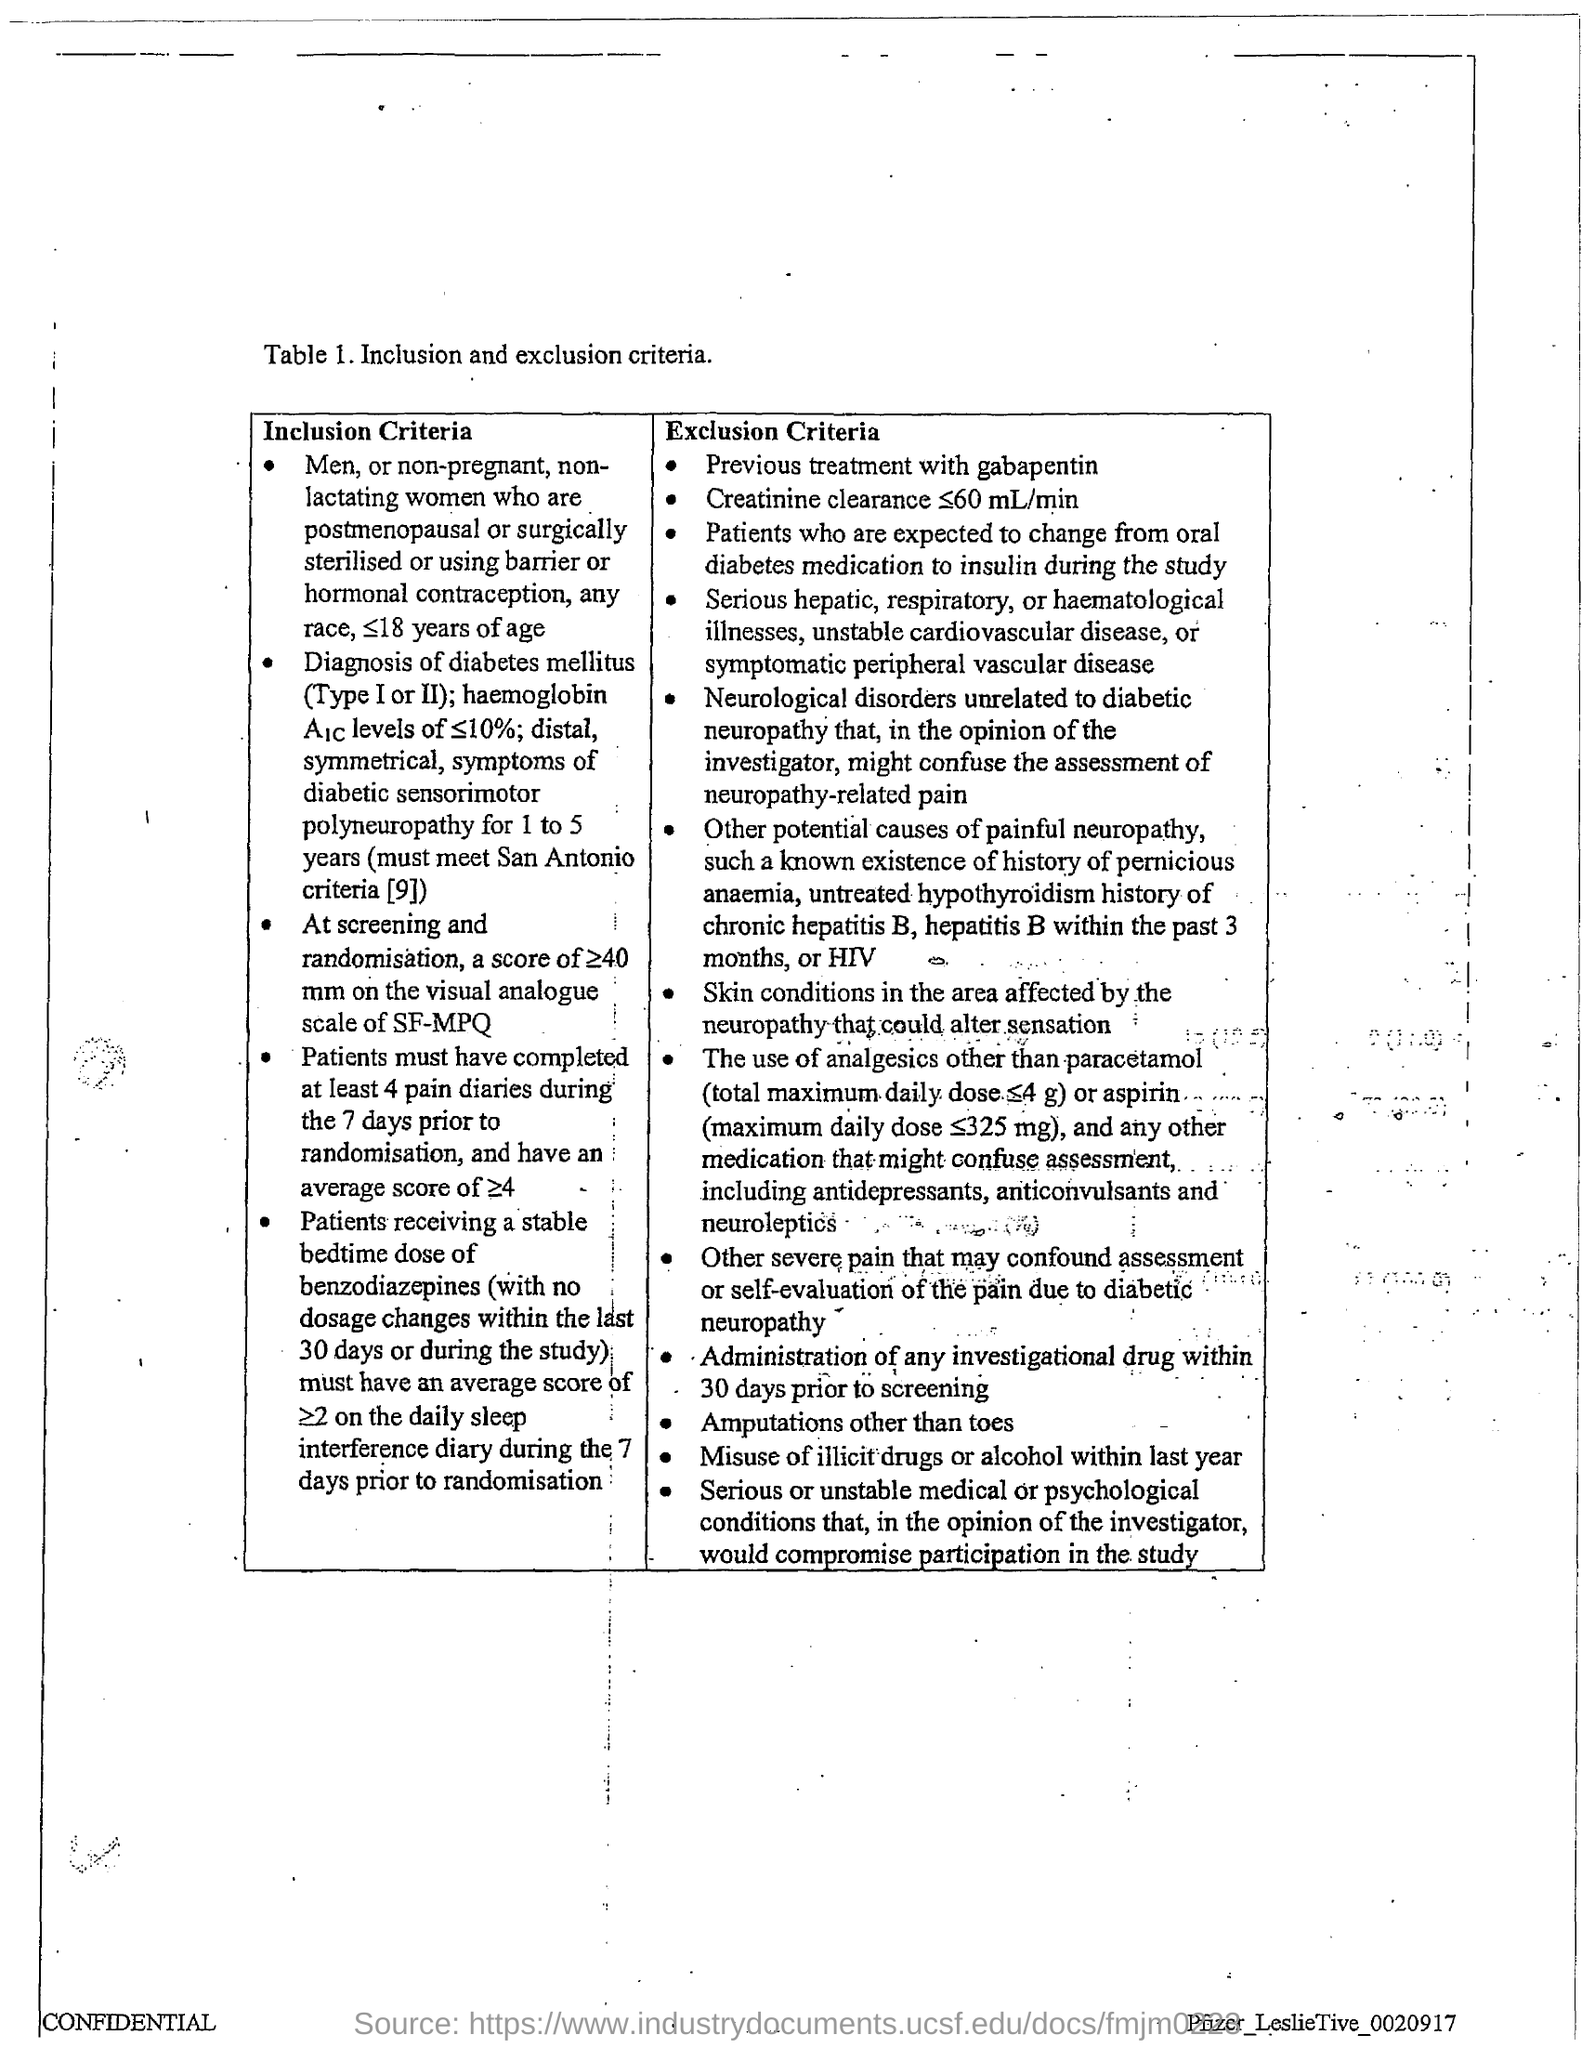Highlight a few significant elements in this photo. Table 1 deals with inclusion and exclusion criteria. 